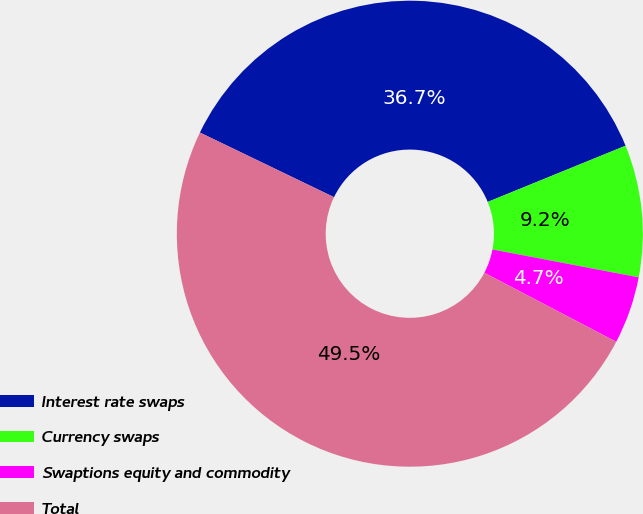<chart> <loc_0><loc_0><loc_500><loc_500><pie_chart><fcel>Interest rate swaps<fcel>Currency swaps<fcel>Swaptions equity and commodity<fcel>Total<nl><fcel>36.69%<fcel>9.16%<fcel>4.68%<fcel>49.47%<nl></chart> 